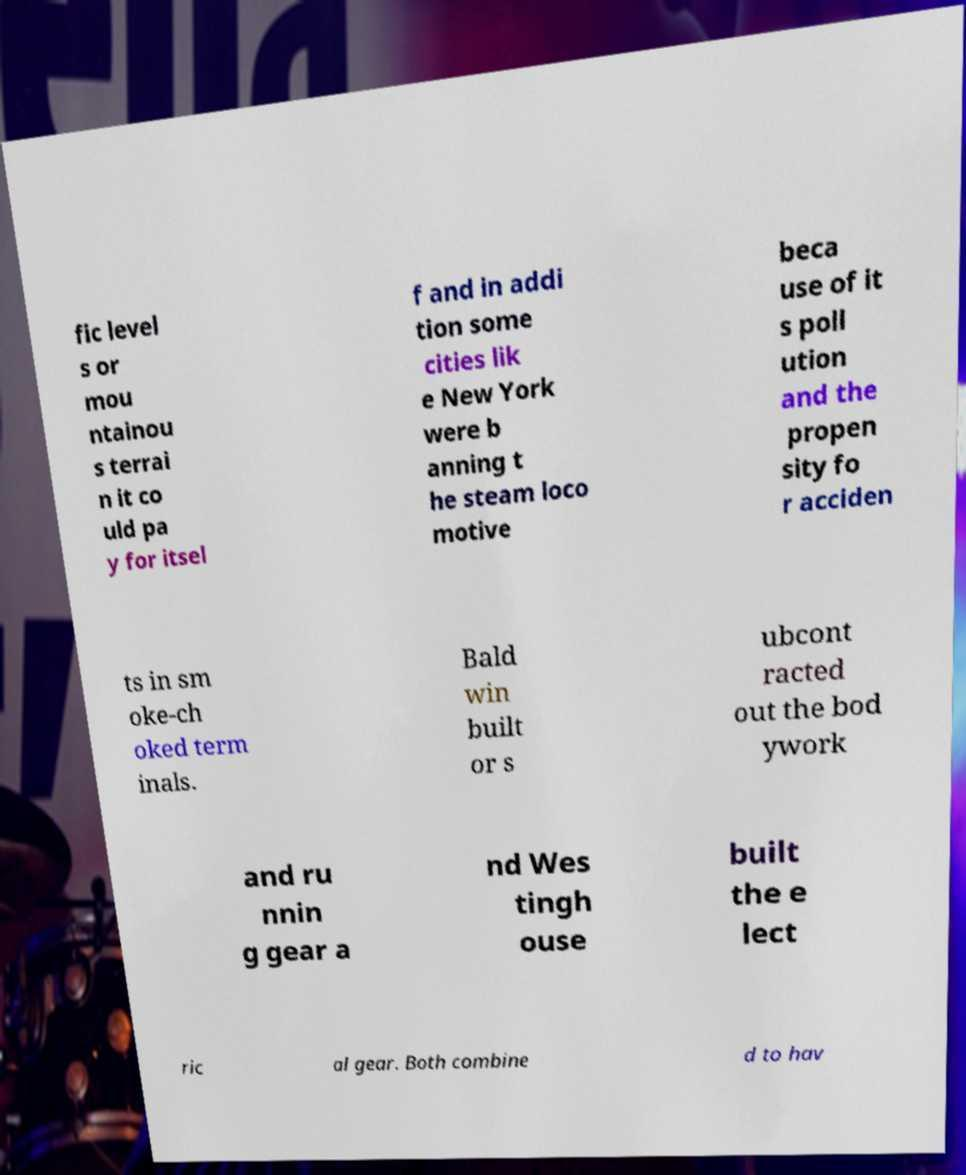Please identify and transcribe the text found in this image. fic level s or mou ntainou s terrai n it co uld pa y for itsel f and in addi tion some cities lik e New York were b anning t he steam loco motive beca use of it s poll ution and the propen sity fo r acciden ts in sm oke-ch oked term inals. Bald win built or s ubcont racted out the bod ywork and ru nnin g gear a nd Wes tingh ouse built the e lect ric al gear. Both combine d to hav 